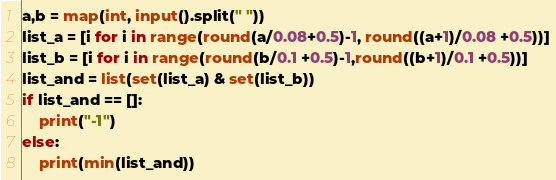Convert code to text. <code><loc_0><loc_0><loc_500><loc_500><_Python_>a,b = map(int, input().split(" "))
list_a = [i for i in range(round(a/0.08+0.5)-1, round((a+1)/0.08 +0.5))]
list_b = [i for i in range(round(b/0.1 +0.5)-1,round((b+1)/0.1 +0.5))]
list_and = list(set(list_a) & set(list_b))
if list_and == []:
    print("-1")
else:
    print(min(list_and))</code> 